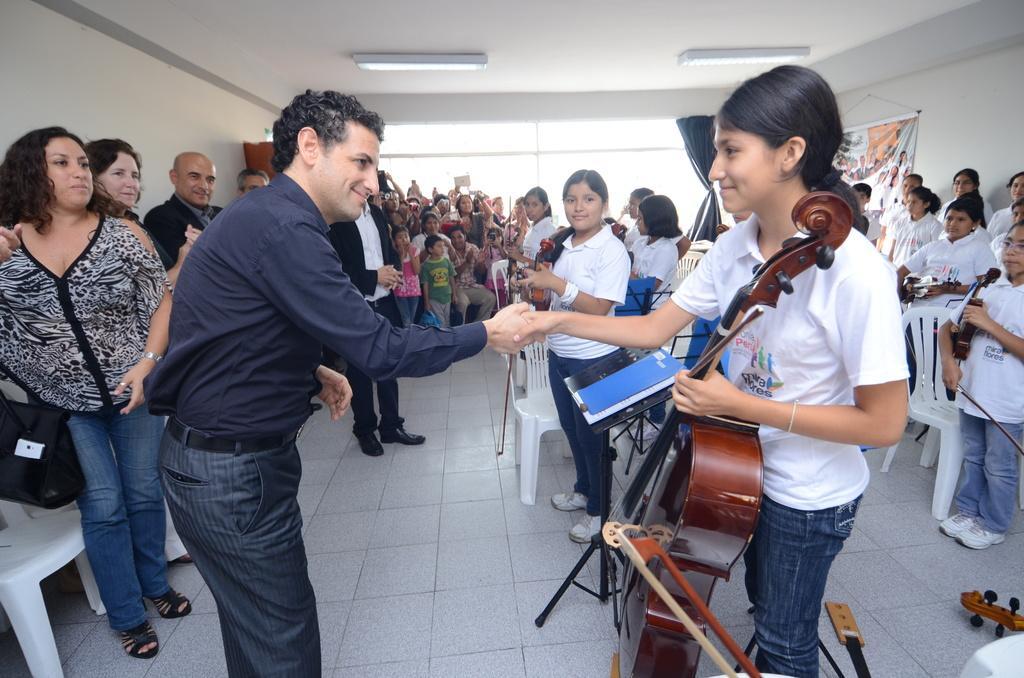Can you describe this image briefly? In this Image I see number of people who are standing and few of them are sitting, I can also see that few of them are holding the musical instruments and I see that these 2 over here are smiling. In the background I see the wall, curtain, banner and lights on the ceiling. 